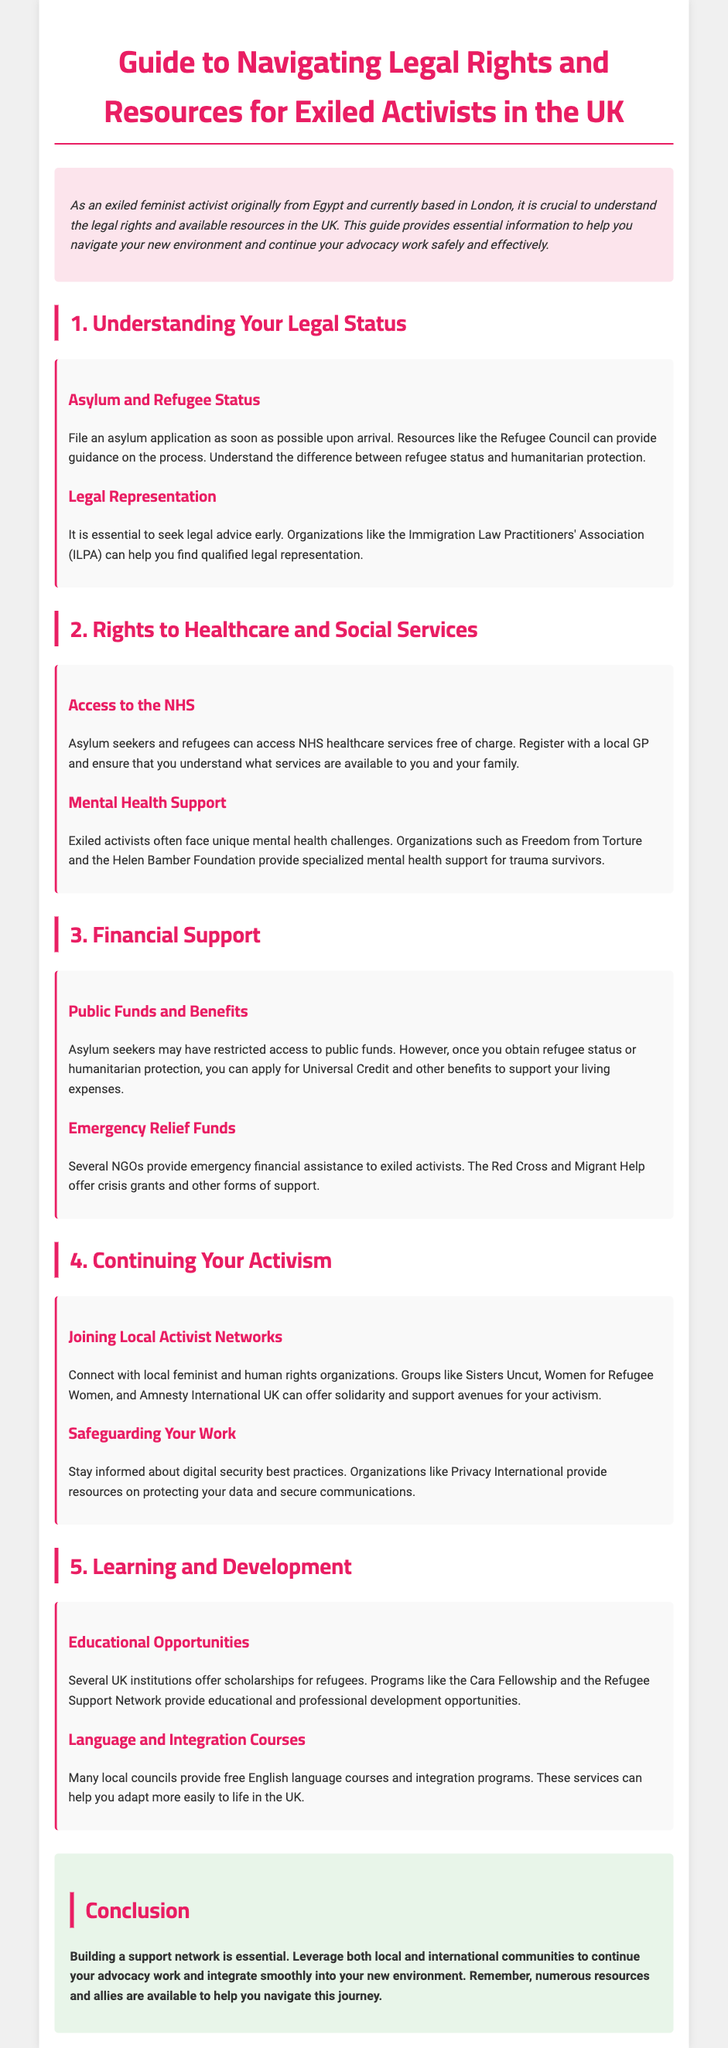what is the title of the guide? The title is presented prominently at the top of the document, which is "Guide to Navigating Legal Rights and Resources for Exiled Activists in the UK."
Answer: Guide to Navigating Legal Rights and Resources for Exiled Activists in the UK who provides guidance on the asylum process? The document mentions the Refugee Council as an organization that can help with the asylum process.
Answer: Refugee Council what can asylum seekers access free of charge? The section detailing rights to healthcare states that asylum seekers and refugees can access NHS healthcare services free of charge.
Answer: NHS healthcare services which organization offers specialized mental health support? The document mentions Freedom from Torture as an organization that provides mental health support for trauma survivors.
Answer: Freedom from Torture what benefit can refugees apply for after obtaining status? The guide specifies that once refugees obtain their status, they can apply for Universal Credit.
Answer: Universal Credit how many sections are in the guide? Counting each section presented in the document, there are five sections dedicated to various aspects of legal rights and resources.
Answer: 5 what is a recommended resource for protecting data? The document advises using resources from Privacy International for safeguarding digital data.
Answer: Privacy International what is the conclusion's focus? The conclusion emphasizes the importance of building a support network to aid in advocacy work and integration into the UK.
Answer: Building a support network which fellowship program is mentioned for educational opportunities? The guide mentions the Cara Fellowship as a program that offers scholarships for refugees.
Answer: Cara Fellowship 